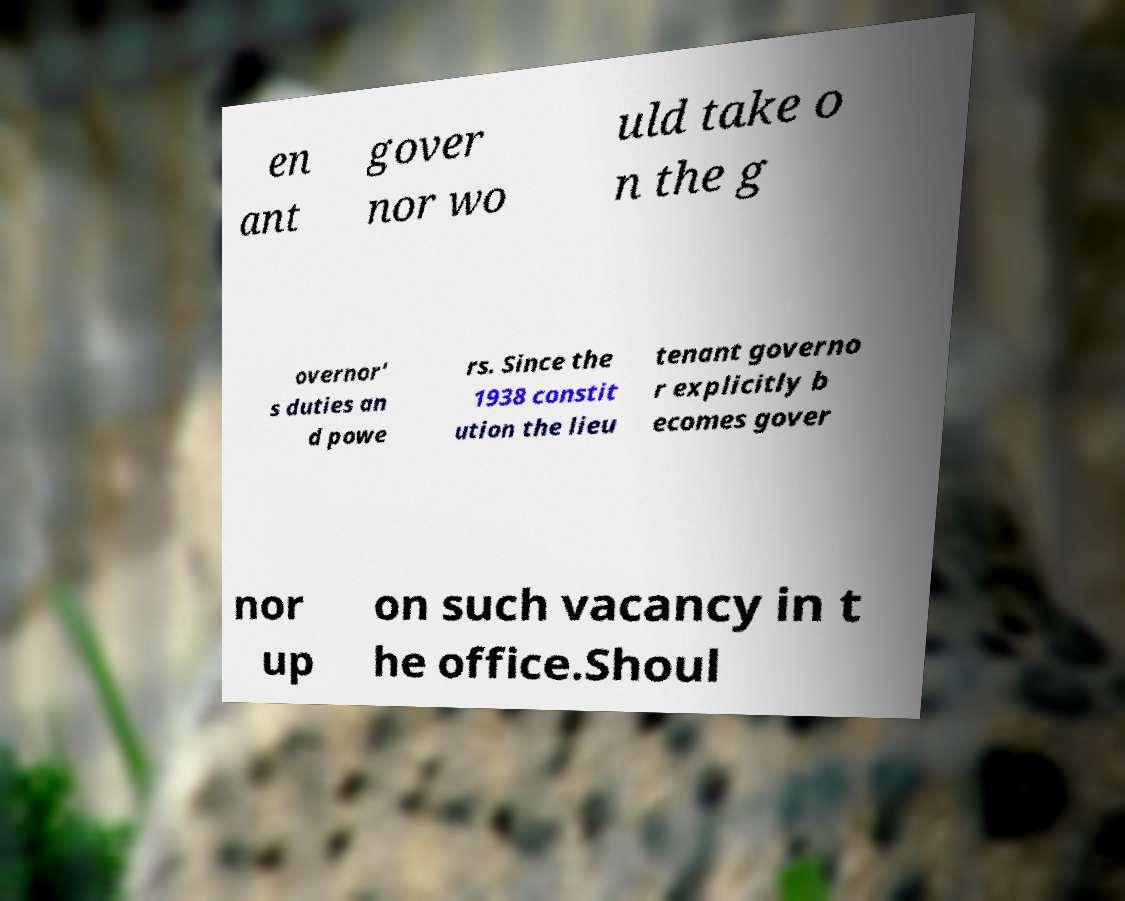Could you extract and type out the text from this image? en ant gover nor wo uld take o n the g overnor' s duties an d powe rs. Since the 1938 constit ution the lieu tenant governo r explicitly b ecomes gover nor up on such vacancy in t he office.Shoul 